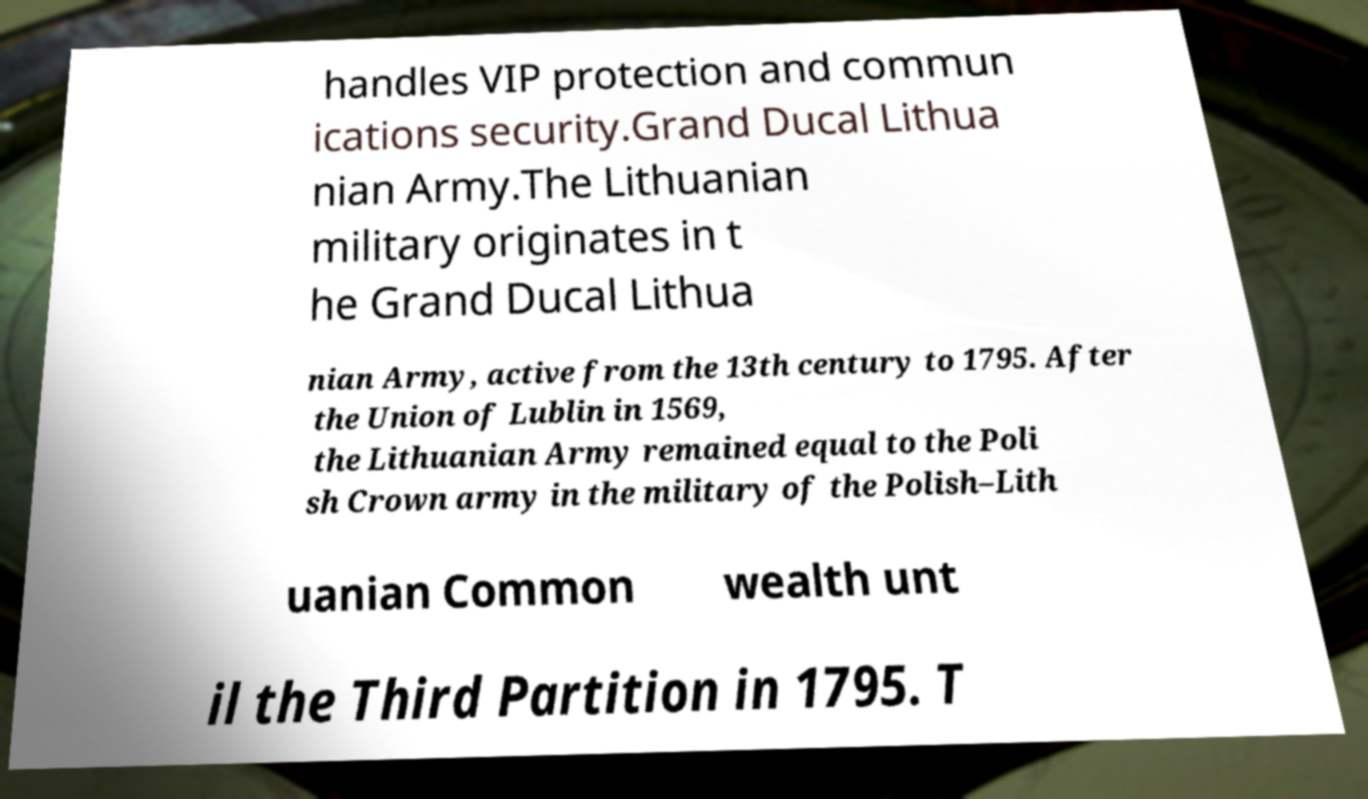Can you accurately transcribe the text from the provided image for me? handles VIP protection and commun ications security.Grand Ducal Lithua nian Army.The Lithuanian military originates in t he Grand Ducal Lithua nian Army, active from the 13th century to 1795. After the Union of Lublin in 1569, the Lithuanian Army remained equal to the Poli sh Crown army in the military of the Polish–Lith uanian Common wealth unt il the Third Partition in 1795. T 